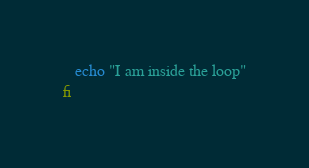Convert code to text. <code><loc_0><loc_0><loc_500><loc_500><_Bash_>   echo "I am inside the loop"
fi
</code> 